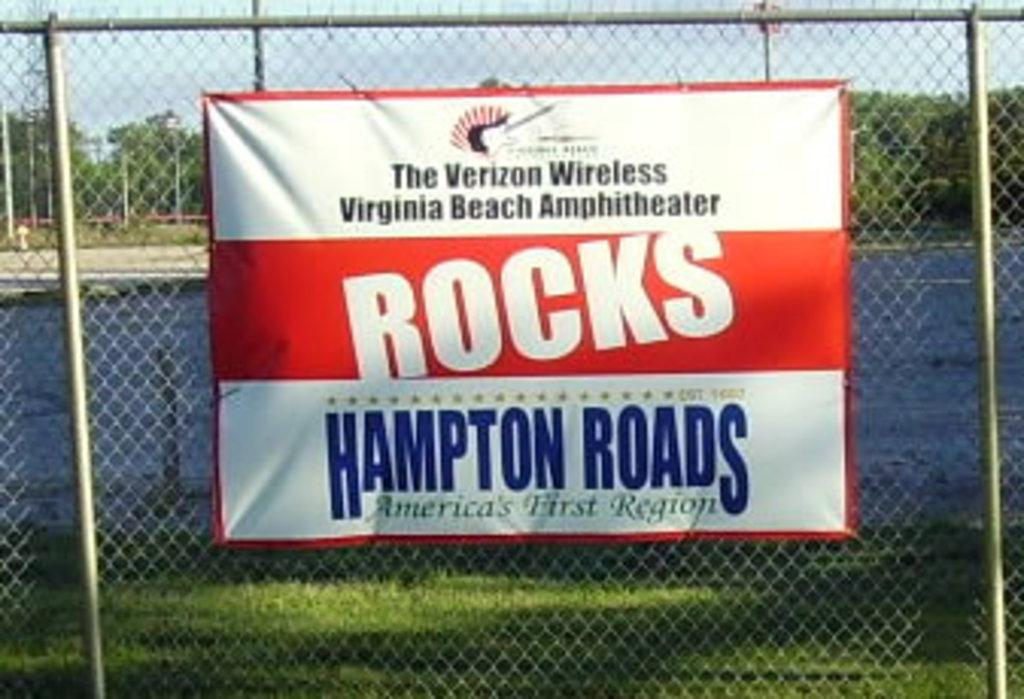What is the main object in the image? There is a board in the image. What else can be seen in the image besides the board? There is a fence, grass, water, trees in the background, poles in the background, and the sky visible in the background. Can you describe the natural elements in the image? There is grass and water in the image, and trees are visible in the background. What is the time of day when the image was taken? The image was taken during the day. How many jellyfish can be seen swimming in the water in the image? There are no jellyfish present in the image; it features a board, a fence, grass, water, trees, poles, and the sky. What type of quill is being used to write on the board in the image? There is no quill present in the image, and the board does not show any writing. 